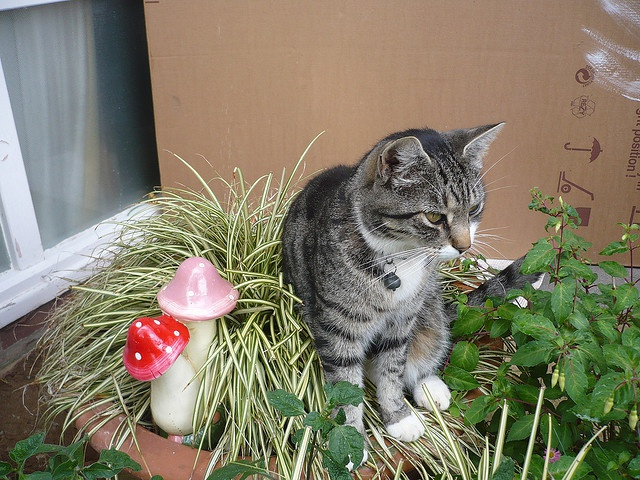Describe the objects in this image and their specific colors. I can see potted plant in lightgray, darkgreen, black, and olive tones, cat in lightgray, gray, darkgray, and black tones, potted plant in lightgray, darkgreen, gray, and green tones, and umbrella in lightgray, brown, maroon, and gray tones in this image. 